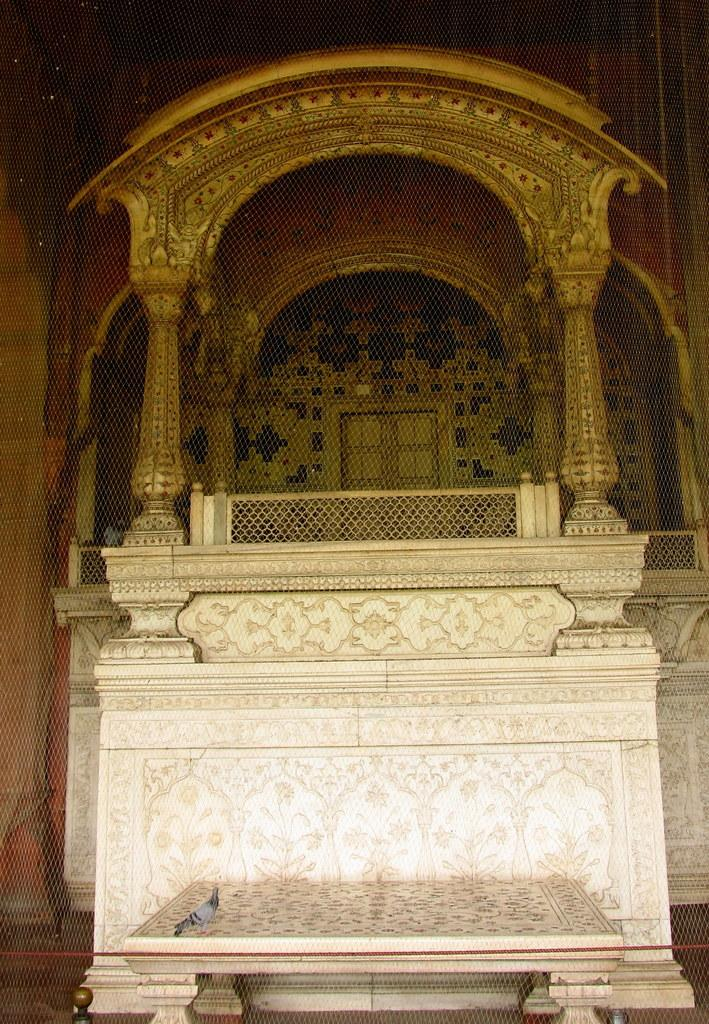What type of architecture is depicted in the image? There is some architecture in the shape of a chair in the image. Can you describe the chair in more detail? The chair has a unique design, but it is not clear what specific type of architecture it represents. What else can be seen in the image? A pigeon is present on the chair. What type of suit is the pigeon wearing in the image? There is no suit present in the image, as pigeons do not wear clothing. 